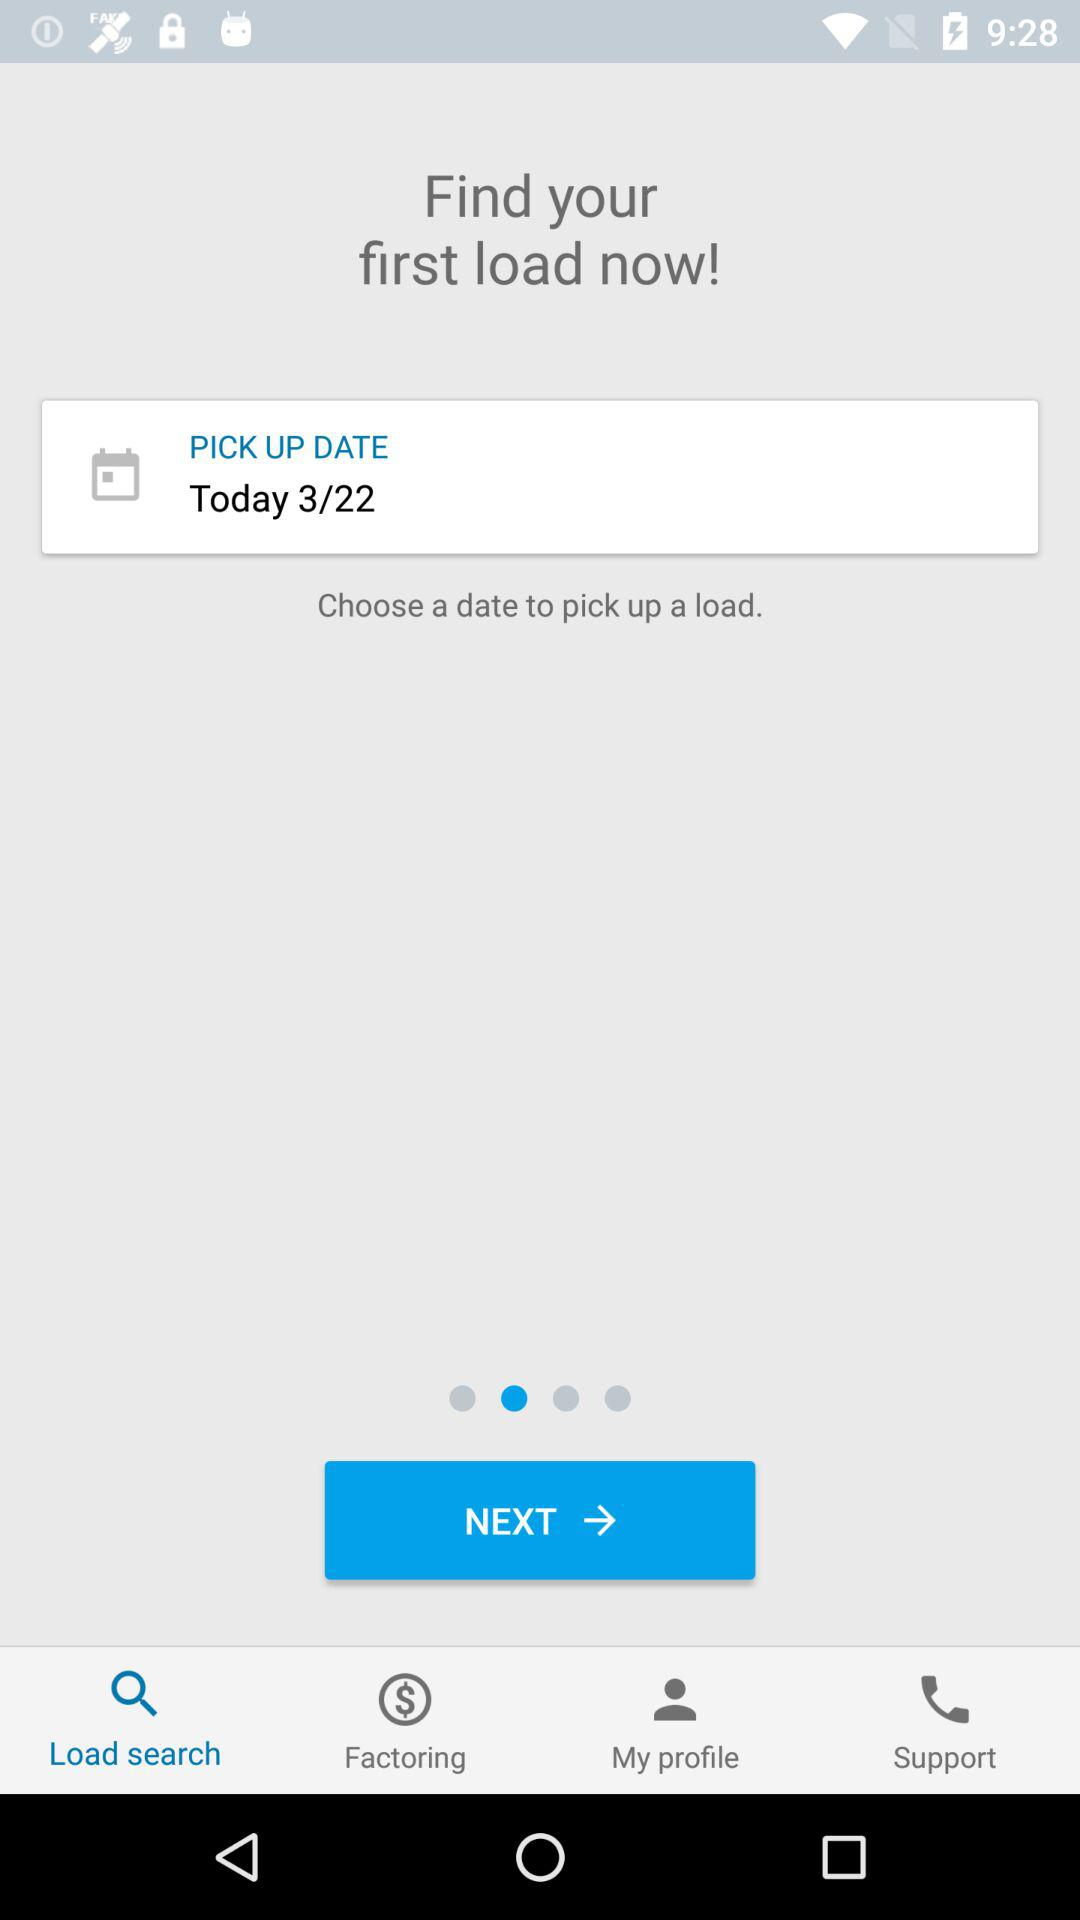What is the purpose of choosing a pickup date on this screen? The purpose of choosing a pickup date on this screen is crucial for planning logistics. It allows users to schedule when to pick up their load, ensuring smooth operations and helping manage their transport activities effectively. 